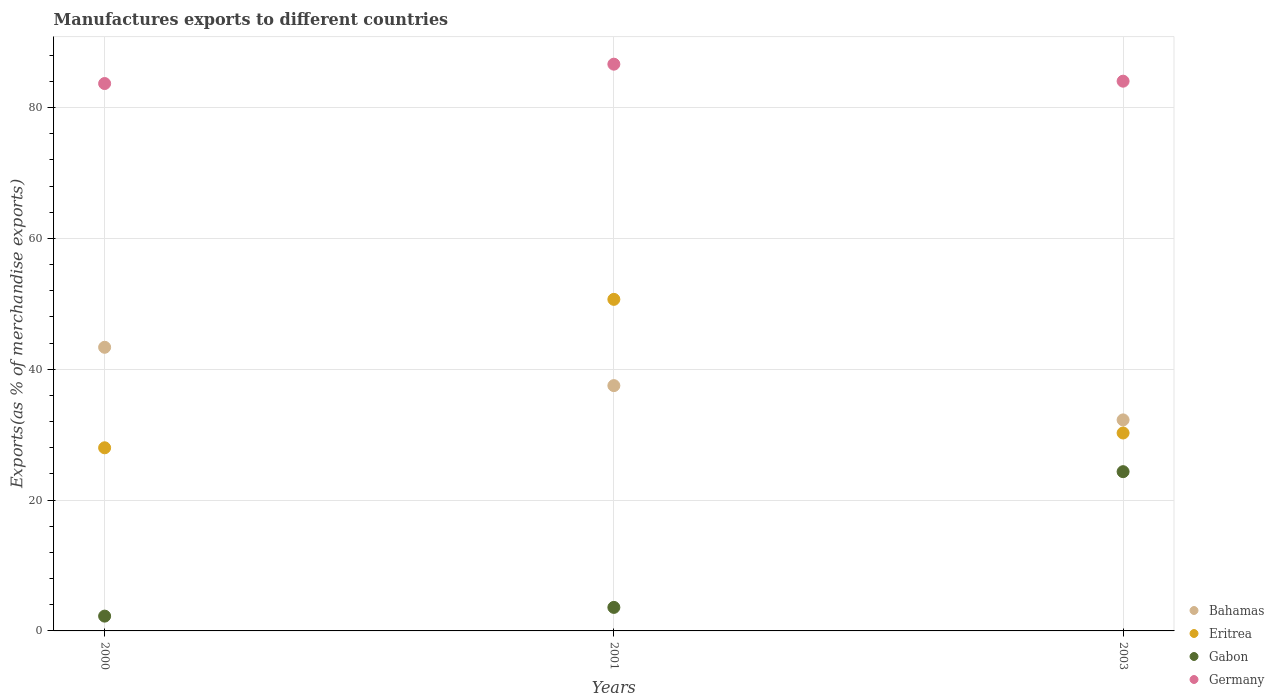How many different coloured dotlines are there?
Offer a very short reply. 4. What is the percentage of exports to different countries in Germany in 2001?
Offer a terse response. 86.63. Across all years, what is the maximum percentage of exports to different countries in Eritrea?
Provide a short and direct response. 50.68. Across all years, what is the minimum percentage of exports to different countries in Eritrea?
Offer a terse response. 27.99. In which year was the percentage of exports to different countries in Eritrea maximum?
Give a very brief answer. 2001. What is the total percentage of exports to different countries in Bahamas in the graph?
Offer a terse response. 113.1. What is the difference between the percentage of exports to different countries in Germany in 2000 and that in 2003?
Make the answer very short. -0.36. What is the difference between the percentage of exports to different countries in Bahamas in 2003 and the percentage of exports to different countries in Eritrea in 2001?
Give a very brief answer. -18.42. What is the average percentage of exports to different countries in Eritrea per year?
Provide a short and direct response. 36.31. In the year 2000, what is the difference between the percentage of exports to different countries in Germany and percentage of exports to different countries in Eritrea?
Your response must be concise. 55.67. In how many years, is the percentage of exports to different countries in Germany greater than 32 %?
Give a very brief answer. 3. What is the ratio of the percentage of exports to different countries in Germany in 2000 to that in 2001?
Ensure brevity in your answer.  0.97. What is the difference between the highest and the second highest percentage of exports to different countries in Germany?
Give a very brief answer. 2.6. What is the difference between the highest and the lowest percentage of exports to different countries in Eritrea?
Your answer should be compact. 22.69. In how many years, is the percentage of exports to different countries in Germany greater than the average percentage of exports to different countries in Germany taken over all years?
Keep it short and to the point. 1. Is it the case that in every year, the sum of the percentage of exports to different countries in Bahamas and percentage of exports to different countries in Gabon  is greater than the sum of percentage of exports to different countries in Eritrea and percentage of exports to different countries in Germany?
Your answer should be very brief. No. Is the percentage of exports to different countries in Gabon strictly greater than the percentage of exports to different countries in Germany over the years?
Ensure brevity in your answer.  No. Is the percentage of exports to different countries in Bahamas strictly less than the percentage of exports to different countries in Gabon over the years?
Make the answer very short. No. How many dotlines are there?
Give a very brief answer. 4. How many years are there in the graph?
Make the answer very short. 3. What is the difference between two consecutive major ticks on the Y-axis?
Your response must be concise. 20. Are the values on the major ticks of Y-axis written in scientific E-notation?
Ensure brevity in your answer.  No. Does the graph contain any zero values?
Make the answer very short. No. How are the legend labels stacked?
Provide a short and direct response. Vertical. What is the title of the graph?
Your answer should be compact. Manufactures exports to different countries. What is the label or title of the X-axis?
Keep it short and to the point. Years. What is the label or title of the Y-axis?
Offer a very short reply. Exports(as % of merchandise exports). What is the Exports(as % of merchandise exports) of Bahamas in 2000?
Make the answer very short. 43.35. What is the Exports(as % of merchandise exports) of Eritrea in 2000?
Your answer should be compact. 27.99. What is the Exports(as % of merchandise exports) in Gabon in 2000?
Your response must be concise. 2.26. What is the Exports(as % of merchandise exports) in Germany in 2000?
Your answer should be very brief. 83.66. What is the Exports(as % of merchandise exports) of Bahamas in 2001?
Offer a terse response. 37.49. What is the Exports(as % of merchandise exports) of Eritrea in 2001?
Offer a very short reply. 50.68. What is the Exports(as % of merchandise exports) in Gabon in 2001?
Keep it short and to the point. 3.6. What is the Exports(as % of merchandise exports) in Germany in 2001?
Your response must be concise. 86.63. What is the Exports(as % of merchandise exports) of Bahamas in 2003?
Provide a succinct answer. 32.25. What is the Exports(as % of merchandise exports) in Eritrea in 2003?
Give a very brief answer. 30.25. What is the Exports(as % of merchandise exports) of Gabon in 2003?
Your response must be concise. 24.34. What is the Exports(as % of merchandise exports) of Germany in 2003?
Your response must be concise. 84.03. Across all years, what is the maximum Exports(as % of merchandise exports) in Bahamas?
Provide a succinct answer. 43.35. Across all years, what is the maximum Exports(as % of merchandise exports) in Eritrea?
Give a very brief answer. 50.68. Across all years, what is the maximum Exports(as % of merchandise exports) of Gabon?
Keep it short and to the point. 24.34. Across all years, what is the maximum Exports(as % of merchandise exports) in Germany?
Keep it short and to the point. 86.63. Across all years, what is the minimum Exports(as % of merchandise exports) of Bahamas?
Provide a short and direct response. 32.25. Across all years, what is the minimum Exports(as % of merchandise exports) of Eritrea?
Keep it short and to the point. 27.99. Across all years, what is the minimum Exports(as % of merchandise exports) in Gabon?
Make the answer very short. 2.26. Across all years, what is the minimum Exports(as % of merchandise exports) of Germany?
Give a very brief answer. 83.66. What is the total Exports(as % of merchandise exports) of Bahamas in the graph?
Keep it short and to the point. 113.1. What is the total Exports(as % of merchandise exports) in Eritrea in the graph?
Your answer should be very brief. 108.92. What is the total Exports(as % of merchandise exports) in Gabon in the graph?
Offer a very short reply. 30.2. What is the total Exports(as % of merchandise exports) in Germany in the graph?
Offer a terse response. 254.32. What is the difference between the Exports(as % of merchandise exports) in Bahamas in 2000 and that in 2001?
Provide a short and direct response. 5.86. What is the difference between the Exports(as % of merchandise exports) in Eritrea in 2000 and that in 2001?
Provide a succinct answer. -22.69. What is the difference between the Exports(as % of merchandise exports) of Gabon in 2000 and that in 2001?
Your answer should be compact. -1.33. What is the difference between the Exports(as % of merchandise exports) of Germany in 2000 and that in 2001?
Ensure brevity in your answer.  -2.96. What is the difference between the Exports(as % of merchandise exports) of Bahamas in 2000 and that in 2003?
Provide a short and direct response. 11.1. What is the difference between the Exports(as % of merchandise exports) of Eritrea in 2000 and that in 2003?
Your response must be concise. -2.26. What is the difference between the Exports(as % of merchandise exports) in Gabon in 2000 and that in 2003?
Make the answer very short. -22.08. What is the difference between the Exports(as % of merchandise exports) of Germany in 2000 and that in 2003?
Offer a terse response. -0.36. What is the difference between the Exports(as % of merchandise exports) of Bahamas in 2001 and that in 2003?
Ensure brevity in your answer.  5.24. What is the difference between the Exports(as % of merchandise exports) of Eritrea in 2001 and that in 2003?
Keep it short and to the point. 20.43. What is the difference between the Exports(as % of merchandise exports) of Gabon in 2001 and that in 2003?
Give a very brief answer. -20.75. What is the difference between the Exports(as % of merchandise exports) in Germany in 2001 and that in 2003?
Your response must be concise. 2.6. What is the difference between the Exports(as % of merchandise exports) in Bahamas in 2000 and the Exports(as % of merchandise exports) in Eritrea in 2001?
Make the answer very short. -7.33. What is the difference between the Exports(as % of merchandise exports) in Bahamas in 2000 and the Exports(as % of merchandise exports) in Gabon in 2001?
Offer a terse response. 39.76. What is the difference between the Exports(as % of merchandise exports) in Bahamas in 2000 and the Exports(as % of merchandise exports) in Germany in 2001?
Offer a very short reply. -43.27. What is the difference between the Exports(as % of merchandise exports) in Eritrea in 2000 and the Exports(as % of merchandise exports) in Gabon in 2001?
Make the answer very short. 24.4. What is the difference between the Exports(as % of merchandise exports) of Eritrea in 2000 and the Exports(as % of merchandise exports) of Germany in 2001?
Provide a short and direct response. -58.63. What is the difference between the Exports(as % of merchandise exports) of Gabon in 2000 and the Exports(as % of merchandise exports) of Germany in 2001?
Ensure brevity in your answer.  -84.36. What is the difference between the Exports(as % of merchandise exports) in Bahamas in 2000 and the Exports(as % of merchandise exports) in Eritrea in 2003?
Your response must be concise. 13.1. What is the difference between the Exports(as % of merchandise exports) in Bahamas in 2000 and the Exports(as % of merchandise exports) in Gabon in 2003?
Provide a short and direct response. 19.01. What is the difference between the Exports(as % of merchandise exports) of Bahamas in 2000 and the Exports(as % of merchandise exports) of Germany in 2003?
Make the answer very short. -40.67. What is the difference between the Exports(as % of merchandise exports) in Eritrea in 2000 and the Exports(as % of merchandise exports) in Gabon in 2003?
Make the answer very short. 3.65. What is the difference between the Exports(as % of merchandise exports) in Eritrea in 2000 and the Exports(as % of merchandise exports) in Germany in 2003?
Provide a short and direct response. -56.03. What is the difference between the Exports(as % of merchandise exports) of Gabon in 2000 and the Exports(as % of merchandise exports) of Germany in 2003?
Provide a short and direct response. -81.76. What is the difference between the Exports(as % of merchandise exports) of Bahamas in 2001 and the Exports(as % of merchandise exports) of Eritrea in 2003?
Provide a succinct answer. 7.24. What is the difference between the Exports(as % of merchandise exports) in Bahamas in 2001 and the Exports(as % of merchandise exports) in Gabon in 2003?
Make the answer very short. 13.15. What is the difference between the Exports(as % of merchandise exports) of Bahamas in 2001 and the Exports(as % of merchandise exports) of Germany in 2003?
Offer a terse response. -46.53. What is the difference between the Exports(as % of merchandise exports) in Eritrea in 2001 and the Exports(as % of merchandise exports) in Gabon in 2003?
Make the answer very short. 26.34. What is the difference between the Exports(as % of merchandise exports) of Eritrea in 2001 and the Exports(as % of merchandise exports) of Germany in 2003?
Offer a very short reply. -33.35. What is the difference between the Exports(as % of merchandise exports) of Gabon in 2001 and the Exports(as % of merchandise exports) of Germany in 2003?
Provide a short and direct response. -80.43. What is the average Exports(as % of merchandise exports) in Bahamas per year?
Keep it short and to the point. 37.7. What is the average Exports(as % of merchandise exports) in Eritrea per year?
Offer a terse response. 36.31. What is the average Exports(as % of merchandise exports) in Gabon per year?
Your answer should be very brief. 10.07. What is the average Exports(as % of merchandise exports) of Germany per year?
Your answer should be very brief. 84.77. In the year 2000, what is the difference between the Exports(as % of merchandise exports) in Bahamas and Exports(as % of merchandise exports) in Eritrea?
Offer a terse response. 15.36. In the year 2000, what is the difference between the Exports(as % of merchandise exports) of Bahamas and Exports(as % of merchandise exports) of Gabon?
Make the answer very short. 41.09. In the year 2000, what is the difference between the Exports(as % of merchandise exports) in Bahamas and Exports(as % of merchandise exports) in Germany?
Keep it short and to the point. -40.31. In the year 2000, what is the difference between the Exports(as % of merchandise exports) in Eritrea and Exports(as % of merchandise exports) in Gabon?
Keep it short and to the point. 25.73. In the year 2000, what is the difference between the Exports(as % of merchandise exports) in Eritrea and Exports(as % of merchandise exports) in Germany?
Offer a very short reply. -55.67. In the year 2000, what is the difference between the Exports(as % of merchandise exports) in Gabon and Exports(as % of merchandise exports) in Germany?
Offer a terse response. -81.4. In the year 2001, what is the difference between the Exports(as % of merchandise exports) of Bahamas and Exports(as % of merchandise exports) of Eritrea?
Give a very brief answer. -13.18. In the year 2001, what is the difference between the Exports(as % of merchandise exports) in Bahamas and Exports(as % of merchandise exports) in Gabon?
Give a very brief answer. 33.9. In the year 2001, what is the difference between the Exports(as % of merchandise exports) in Bahamas and Exports(as % of merchandise exports) in Germany?
Offer a terse response. -49.13. In the year 2001, what is the difference between the Exports(as % of merchandise exports) of Eritrea and Exports(as % of merchandise exports) of Gabon?
Give a very brief answer. 47.08. In the year 2001, what is the difference between the Exports(as % of merchandise exports) in Eritrea and Exports(as % of merchandise exports) in Germany?
Ensure brevity in your answer.  -35.95. In the year 2001, what is the difference between the Exports(as % of merchandise exports) of Gabon and Exports(as % of merchandise exports) of Germany?
Provide a succinct answer. -83.03. In the year 2003, what is the difference between the Exports(as % of merchandise exports) in Bahamas and Exports(as % of merchandise exports) in Eritrea?
Offer a terse response. 2. In the year 2003, what is the difference between the Exports(as % of merchandise exports) in Bahamas and Exports(as % of merchandise exports) in Gabon?
Your answer should be compact. 7.91. In the year 2003, what is the difference between the Exports(as % of merchandise exports) in Bahamas and Exports(as % of merchandise exports) in Germany?
Offer a very short reply. -51.77. In the year 2003, what is the difference between the Exports(as % of merchandise exports) of Eritrea and Exports(as % of merchandise exports) of Gabon?
Your answer should be compact. 5.91. In the year 2003, what is the difference between the Exports(as % of merchandise exports) of Eritrea and Exports(as % of merchandise exports) of Germany?
Provide a short and direct response. -53.77. In the year 2003, what is the difference between the Exports(as % of merchandise exports) in Gabon and Exports(as % of merchandise exports) in Germany?
Offer a terse response. -59.69. What is the ratio of the Exports(as % of merchandise exports) in Bahamas in 2000 to that in 2001?
Give a very brief answer. 1.16. What is the ratio of the Exports(as % of merchandise exports) in Eritrea in 2000 to that in 2001?
Offer a very short reply. 0.55. What is the ratio of the Exports(as % of merchandise exports) in Gabon in 2000 to that in 2001?
Offer a terse response. 0.63. What is the ratio of the Exports(as % of merchandise exports) of Germany in 2000 to that in 2001?
Offer a very short reply. 0.97. What is the ratio of the Exports(as % of merchandise exports) in Bahamas in 2000 to that in 2003?
Offer a very short reply. 1.34. What is the ratio of the Exports(as % of merchandise exports) in Eritrea in 2000 to that in 2003?
Your answer should be very brief. 0.93. What is the ratio of the Exports(as % of merchandise exports) of Gabon in 2000 to that in 2003?
Give a very brief answer. 0.09. What is the ratio of the Exports(as % of merchandise exports) of Germany in 2000 to that in 2003?
Offer a terse response. 1. What is the ratio of the Exports(as % of merchandise exports) of Bahamas in 2001 to that in 2003?
Provide a short and direct response. 1.16. What is the ratio of the Exports(as % of merchandise exports) in Eritrea in 2001 to that in 2003?
Your answer should be compact. 1.68. What is the ratio of the Exports(as % of merchandise exports) of Gabon in 2001 to that in 2003?
Your answer should be very brief. 0.15. What is the ratio of the Exports(as % of merchandise exports) in Germany in 2001 to that in 2003?
Provide a succinct answer. 1.03. What is the difference between the highest and the second highest Exports(as % of merchandise exports) of Bahamas?
Make the answer very short. 5.86. What is the difference between the highest and the second highest Exports(as % of merchandise exports) in Eritrea?
Your response must be concise. 20.43. What is the difference between the highest and the second highest Exports(as % of merchandise exports) of Gabon?
Your response must be concise. 20.75. What is the difference between the highest and the second highest Exports(as % of merchandise exports) of Germany?
Make the answer very short. 2.6. What is the difference between the highest and the lowest Exports(as % of merchandise exports) of Bahamas?
Provide a succinct answer. 11.1. What is the difference between the highest and the lowest Exports(as % of merchandise exports) of Eritrea?
Your answer should be compact. 22.69. What is the difference between the highest and the lowest Exports(as % of merchandise exports) of Gabon?
Make the answer very short. 22.08. What is the difference between the highest and the lowest Exports(as % of merchandise exports) of Germany?
Make the answer very short. 2.96. 